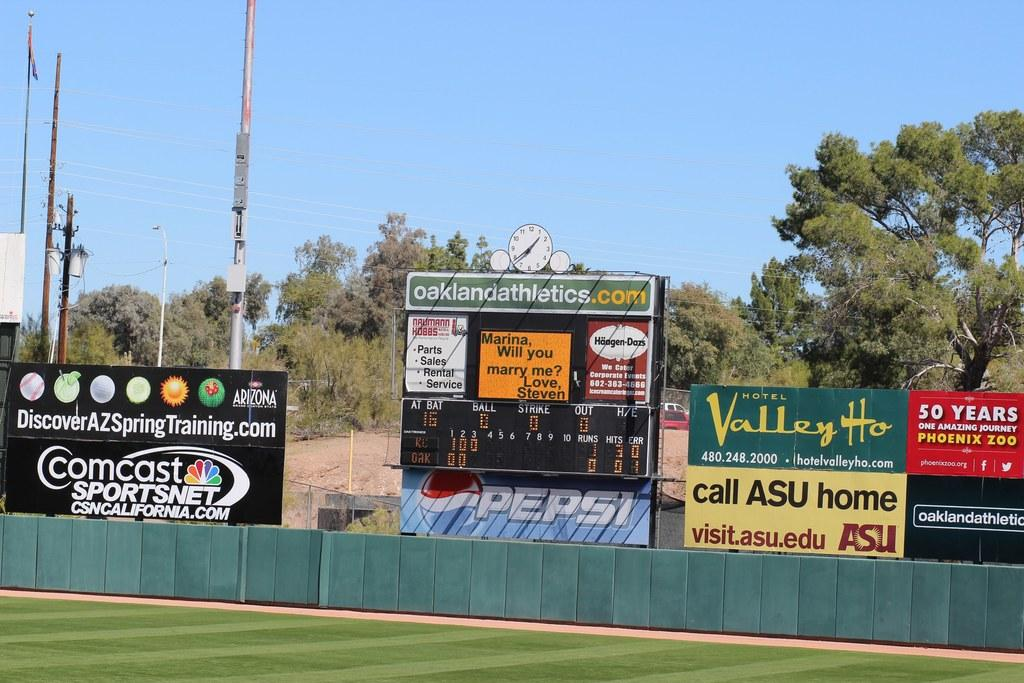<image>
Render a clear and concise summary of the photo. Baseball field that is being televised by Comcast Sportsnet. 